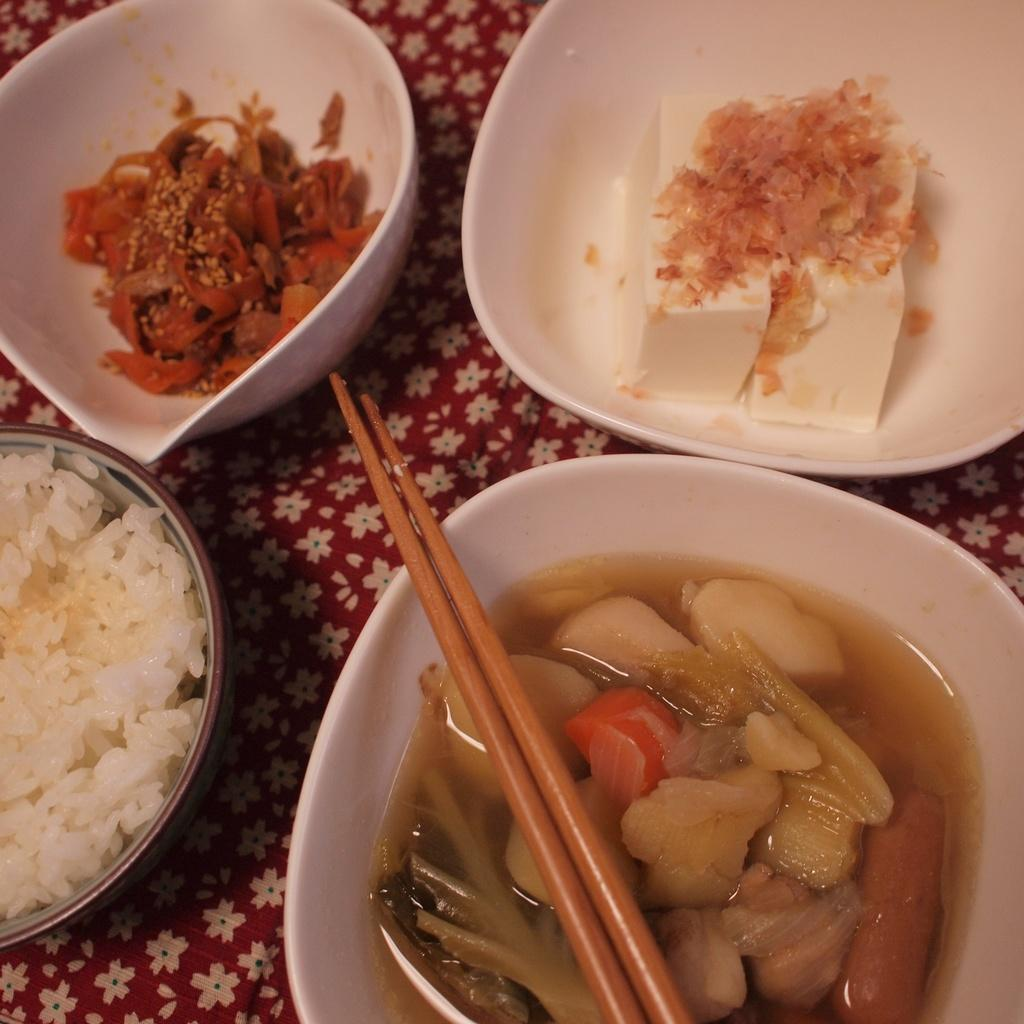What piece of furniture can be seen in the image? There is a table in the image. What is placed on the table? There are bowls on the table. What utensils are present on the table? Chopsticks are present on the table. What is inside the bowls on the table? There are dishes in the bowls. What type of alarm can be heard going off in the image? There is no alarm present or audible in the image. Can you tell me where the nearest market is in the image? A: There is no reference to a market or its location in the image. Is there a tank visible in the image? There is no tank present in the image. 